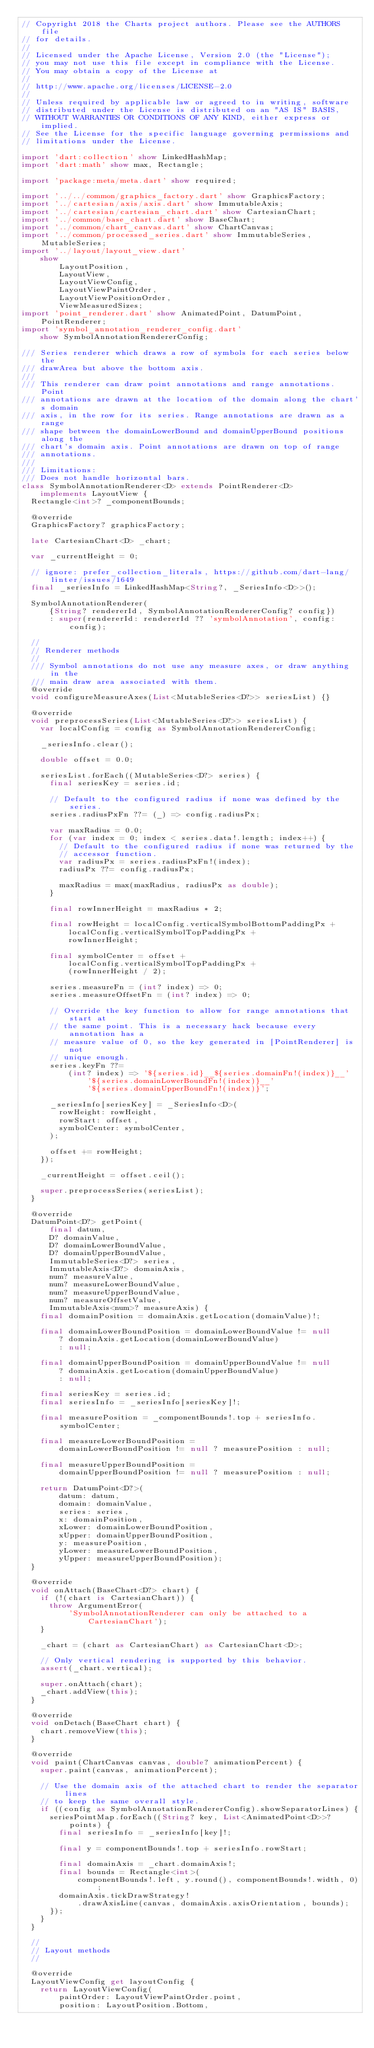Convert code to text. <code><loc_0><loc_0><loc_500><loc_500><_Dart_>// Copyright 2018 the Charts project authors. Please see the AUTHORS file
// for details.
//
// Licensed under the Apache License, Version 2.0 (the "License");
// you may not use this file except in compliance with the License.
// You may obtain a copy of the License at
//
// http://www.apache.org/licenses/LICENSE-2.0
//
// Unless required by applicable law or agreed to in writing, software
// distributed under the License is distributed on an "AS IS" BASIS,
// WITHOUT WARRANTIES OR CONDITIONS OF ANY KIND, either express or implied.
// See the License for the specific language governing permissions and
// limitations under the License.

import 'dart:collection' show LinkedHashMap;
import 'dart:math' show max, Rectangle;

import 'package:meta/meta.dart' show required;

import '../../common/graphics_factory.dart' show GraphicsFactory;
import '../cartesian/axis/axis.dart' show ImmutableAxis;
import '../cartesian/cartesian_chart.dart' show CartesianChart;
import '../common/base_chart.dart' show BaseChart;
import '../common/chart_canvas.dart' show ChartCanvas;
import '../common/processed_series.dart' show ImmutableSeries, MutableSeries;
import '../layout/layout_view.dart'
    show
        LayoutPosition,
        LayoutView,
        LayoutViewConfig,
        LayoutViewPaintOrder,
        LayoutViewPositionOrder,
        ViewMeasuredSizes;
import 'point_renderer.dart' show AnimatedPoint, DatumPoint, PointRenderer;
import 'symbol_annotation_renderer_config.dart'
    show SymbolAnnotationRendererConfig;

/// Series renderer which draws a row of symbols for each series below the
/// drawArea but above the bottom axis.
///
/// This renderer can draw point annotations and range annotations. Point
/// annotations are drawn at the location of the domain along the chart's domain
/// axis, in the row for its series. Range annotations are drawn as a range
/// shape between the domainLowerBound and domainUpperBound positions along the
/// chart's domain axis. Point annotations are drawn on top of range
/// annotations.
///
/// Limitations:
/// Does not handle horizontal bars.
class SymbolAnnotationRenderer<D> extends PointRenderer<D>
    implements LayoutView {
  Rectangle<int>? _componentBounds;

  @override
  GraphicsFactory? graphicsFactory;

  late CartesianChart<D> _chart;

  var _currentHeight = 0;

  // ignore: prefer_collection_literals, https://github.com/dart-lang/linter/issues/1649
  final _seriesInfo = LinkedHashMap<String?, _SeriesInfo<D>>();

  SymbolAnnotationRenderer(
      {String? rendererId, SymbolAnnotationRendererConfig? config})
      : super(rendererId: rendererId ?? 'symbolAnnotation', config: config);

  //
  // Renderer methods
  //
  /// Symbol annotations do not use any measure axes, or draw anything in the
  /// main draw area associated with them.
  @override
  void configureMeasureAxes(List<MutableSeries<D?>> seriesList) {}

  @override
  void preprocessSeries(List<MutableSeries<D?>> seriesList) {
    var localConfig = config as SymbolAnnotationRendererConfig;

    _seriesInfo.clear();

    double offset = 0.0;

    seriesList.forEach((MutableSeries<D?> series) {
      final seriesKey = series.id;

      // Default to the configured radius if none was defined by the series.
      series.radiusPxFn ??= (_) => config.radiusPx;

      var maxRadius = 0.0;
      for (var index = 0; index < series.data!.length; index++) {
        // Default to the configured radius if none was returned by the
        // accessor function.
        var radiusPx = series.radiusPxFn!(index);
        radiusPx ??= config.radiusPx;

        maxRadius = max(maxRadius, radiusPx as double);
      }

      final rowInnerHeight = maxRadius * 2;

      final rowHeight = localConfig.verticalSymbolBottomPaddingPx +
          localConfig.verticalSymbolTopPaddingPx +
          rowInnerHeight;

      final symbolCenter = offset +
          localConfig.verticalSymbolTopPaddingPx +
          (rowInnerHeight / 2);

      series.measureFn = (int? index) => 0;
      series.measureOffsetFn = (int? index) => 0;

      // Override the key function to allow for range annotations that start at
      // the same point. This is a necessary hack because every annotation has a
      // measure value of 0, so the key generated in [PointRenderer] is not
      // unique enough.
      series.keyFn ??=
          (int? index) => '${series.id}__${series.domainFn!(index)}__'
              '${series.domainLowerBoundFn!(index)}__'
              '${series.domainUpperBoundFn!(index)}';

      _seriesInfo[seriesKey] = _SeriesInfo<D>(
        rowHeight: rowHeight,
        rowStart: offset,
        symbolCenter: symbolCenter,
      );

      offset += rowHeight;
    });

    _currentHeight = offset.ceil();

    super.preprocessSeries(seriesList);
  }

  @override
  DatumPoint<D?> getPoint(
      final datum,
      D? domainValue,
      D? domainLowerBoundValue,
      D? domainUpperBoundValue,
      ImmutableSeries<D?> series,
      ImmutableAxis<D?> domainAxis,
      num? measureValue,
      num? measureLowerBoundValue,
      num? measureUpperBoundValue,
      num? measureOffsetValue,
      ImmutableAxis<num>? measureAxis) {
    final domainPosition = domainAxis.getLocation(domainValue)!;

    final domainLowerBoundPosition = domainLowerBoundValue != null
        ? domainAxis.getLocation(domainLowerBoundValue)
        : null;

    final domainUpperBoundPosition = domainUpperBoundValue != null
        ? domainAxis.getLocation(domainUpperBoundValue)
        : null;

    final seriesKey = series.id;
    final seriesInfo = _seriesInfo[seriesKey]!;

    final measurePosition = _componentBounds!.top + seriesInfo.symbolCenter;

    final measureLowerBoundPosition =
        domainLowerBoundPosition != null ? measurePosition : null;

    final measureUpperBoundPosition =
        domainUpperBoundPosition != null ? measurePosition : null;

    return DatumPoint<D?>(
        datum: datum,
        domain: domainValue,
        series: series,
        x: domainPosition,
        xLower: domainLowerBoundPosition,
        xUpper: domainUpperBoundPosition,
        y: measurePosition,
        yLower: measureLowerBoundPosition,
        yUpper: measureUpperBoundPosition);
  }

  @override
  void onAttach(BaseChart<D?> chart) {
    if (!(chart is CartesianChart)) {
      throw ArgumentError(
          'SymbolAnnotationRenderer can only be attached to a CartesianChart');
    }

    _chart = (chart as CartesianChart) as CartesianChart<D>;

    // Only vertical rendering is supported by this behavior.
    assert(_chart.vertical);

    super.onAttach(chart);
    _chart.addView(this);
  }

  @override
  void onDetach(BaseChart chart) {
    chart.removeView(this);
  }

  @override
  void paint(ChartCanvas canvas, double? animationPercent) {
    super.paint(canvas, animationPercent);

    // Use the domain axis of the attached chart to render the separator lines
    // to keep the same overall style.
    if ((config as SymbolAnnotationRendererConfig).showSeparatorLines) {
      seriesPointMap.forEach((String? key, List<AnimatedPoint<D>>? points) {
        final seriesInfo = _seriesInfo[key]!;

        final y = componentBounds!.top + seriesInfo.rowStart;

        final domainAxis = _chart.domainAxis!;
        final bounds = Rectangle<int>(
            componentBounds!.left, y.round(), componentBounds!.width, 0);
        domainAxis.tickDrawStrategy!
            .drawAxisLine(canvas, domainAxis.axisOrientation, bounds);
      });
    }
  }

  //
  // Layout methods
  //

  @override
  LayoutViewConfig get layoutConfig {
    return LayoutViewConfig(
        paintOrder: LayoutViewPaintOrder.point,
        position: LayoutPosition.Bottom,</code> 